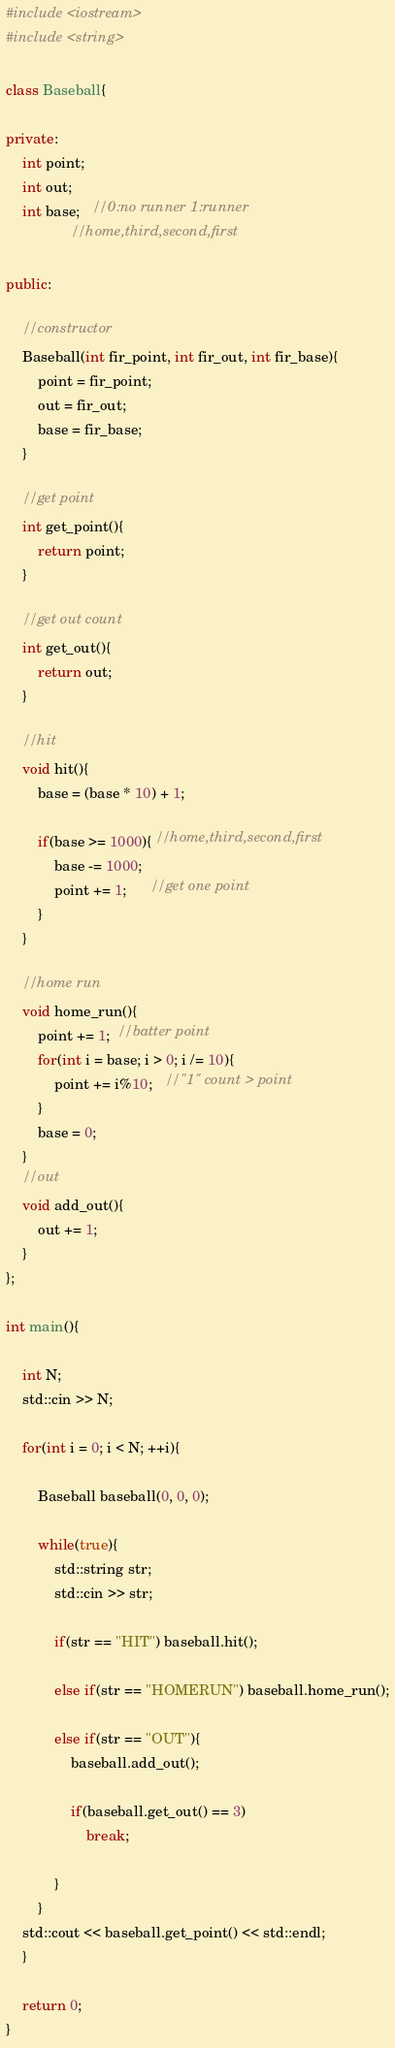Convert code to text. <code><loc_0><loc_0><loc_500><loc_500><_C++_>#include <iostream>
#include <string>

class Baseball{

private:
	int point;
	int out;
	int base;   //0:no runner 1:runner
				//home,third,second,first

public:
	
	//constructor
	Baseball(int fir_point, int fir_out, int fir_base){
		point = fir_point;
		out = fir_out;
		base = fir_base;
	}

	//get point
	int get_point(){
		return point;
	}
	
	//get out count
	int get_out(){
		return out;
	}

	//hit
	void hit(){
		base = (base * 10) + 1;
		
		if(base >= 1000){ //home,third,second,first
			base -= 1000; 
			point += 1;	  //get one point
		}
	}
    
	//home run
	void home_run(){
		point += 1;  //batter point
		for(int i = base; i > 0; i /= 10){
			point += i%10;   //"1" count > point
		}
		base = 0;
	}
    //out
	void add_out(){
		out += 1;
	}
};	

int main(){

	int N;
	std::cin >> N;

	for(int i = 0; i < N; ++i){

		Baseball baseball(0, 0, 0);

		while(true){
			std::string str;
			std::cin >> str;

			if(str == "HIT") baseball.hit();
			
			else if(str == "HOMERUN") baseball.home_run();

			else if(str == "OUT"){
				baseball.add_out();
			
				if(baseball.get_out() == 3)
					break;
				
			}
		}
	std::cout << baseball.get_point() << std::endl;
	}

	return 0;
}</code> 